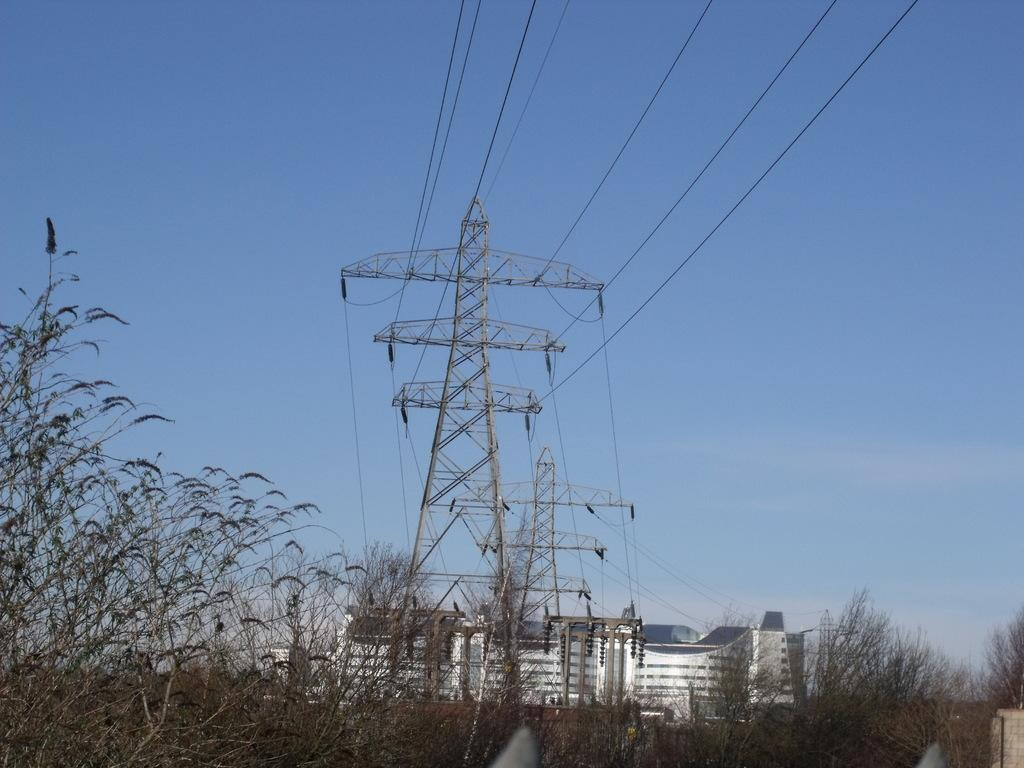What is the main structure in the image? There is an electric tower in the image. Where is the electric tower located in relation to other structures? The electric tower is in front of a building. What type of vegetation can be seen in the image? There are plants in the bottom left of the image. What can be seen in the distance in the image? The sky is visible in the background of the image. Can you see your friend waving from the airport in the image? There is no airport or friend visible in the image; it features an electric tower in front of a building with plants and a visible sky in the background. 